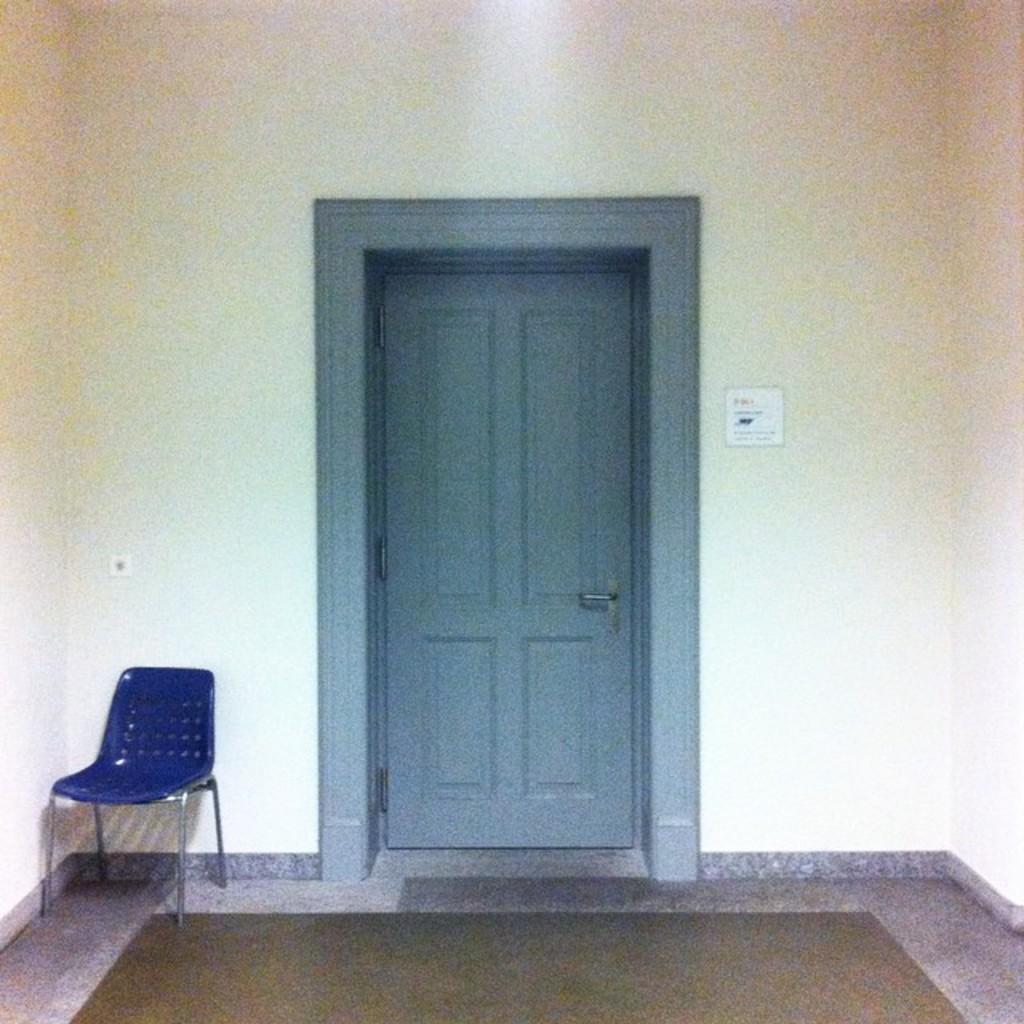In one or two sentences, can you explain what this image depicts? Here we can see a wooden door. In-front of this wall there is a blue chair. 